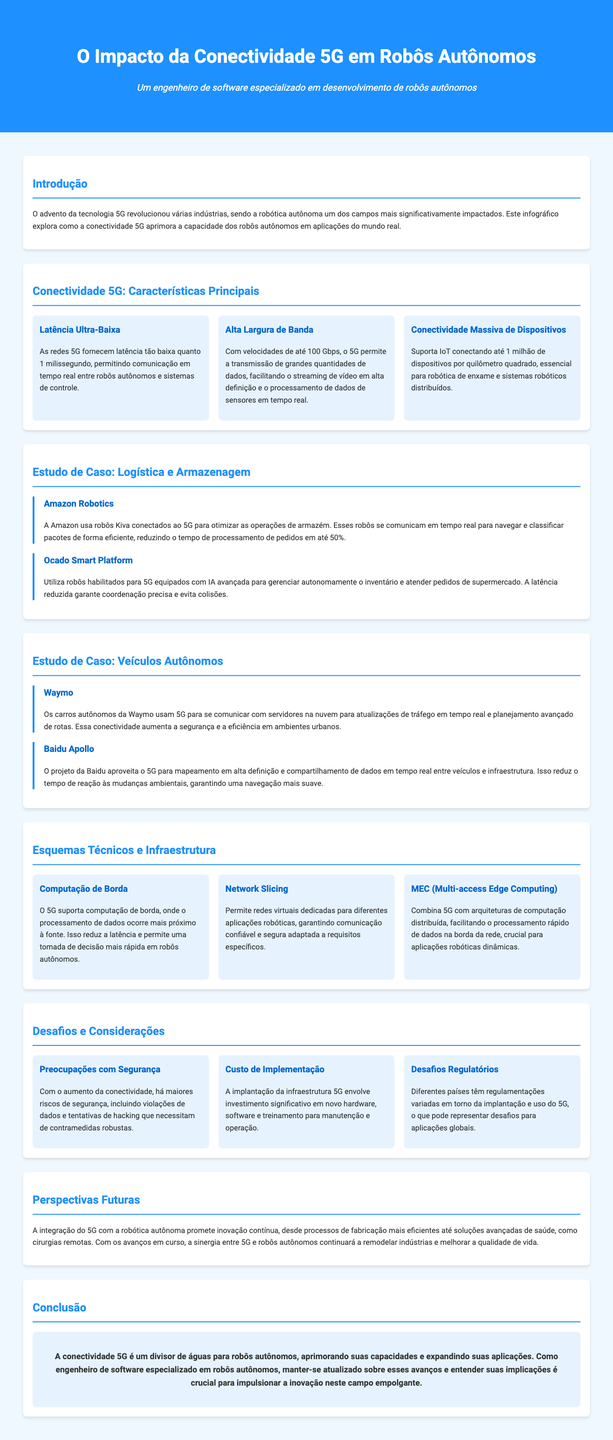qual é a latência do 5G? O 5G fornece latência tão baixa quanto 1 milissegundo, conforme mencionado na seção sobre características principais.
Answer: 1 milissegundo qual é a velocidade máxima do 5G? A velocidade máxima do 5G é de até 100 Gbps, conforme indicado na mesma seção.
Answer: 100 Gbps quem utiliza robôs Kiva? A Amazon utiliza robôs Kiva, de acordo com o estudo de caso sobre logística e armazenagem.
Answer: Amazon qual é a função dos robôs da Ocado? Os robôs da Ocado gerenciam autonomamente o inventário, como descrito no estudo de caso correspondente.
Answer: Gerenciar autonomamente o inventário quais são as preocupações associadas à conectividade 5G? As preocupações incluem violações de dados e tentativas de hacking, conforme discutido na seção sobre desafios e considerações.
Answer: Violações de dados e tentativas de hacking como o 5G afeta a navegação de veículos autônomos? O 5G ajuda na comunicação de servidores na nuvem para atualizações de tráfego e planejamento de rotas, como mencionado na seção de veículos autônomos.
Answer: Atualizações de tráfego e planejamento de rotas qual é a promessa da integração do 5G com a robótica autônoma? A promessa inclui inovação contínua em processos de fabricação e soluções avançadas de saúde, conforme descrito na seção de perspectivas futuras.
Answer: Inovação contínua o que é Network Slicing? Network Slicing permite redes virtuais dedicadas para diferentes aplicações robóticas, explicado na seção de esquemas técnicos e infraestrutura.
Answer: Redes virtuais dedicadas qual é o impacto da conectividade 5G em robôs autônomos? A conectividade 5G aprimora as capacidades dos robôs autônomos, conforme concluído na seção de conclusão.
Answer: Aprimora as capacidades 